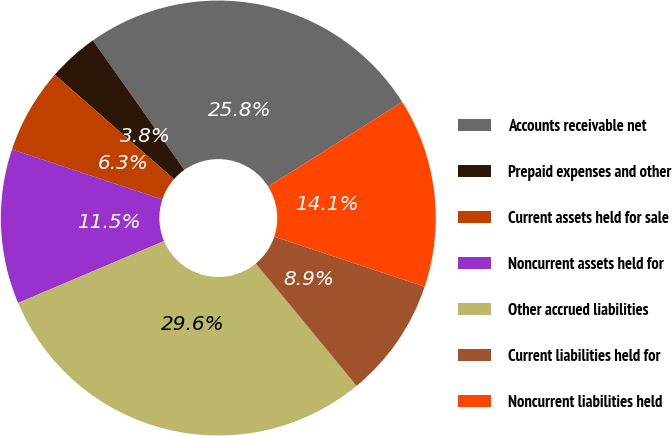Convert chart. <chart><loc_0><loc_0><loc_500><loc_500><pie_chart><fcel>Accounts receivable net<fcel>Prepaid expenses and other<fcel>Current assets held for sale<fcel>Noncurrent assets held for<fcel>Other accrued liabilities<fcel>Current liabilities held for<fcel>Noncurrent liabilities held<nl><fcel>25.82%<fcel>3.76%<fcel>6.34%<fcel>11.5%<fcel>29.58%<fcel>8.92%<fcel>14.08%<nl></chart> 